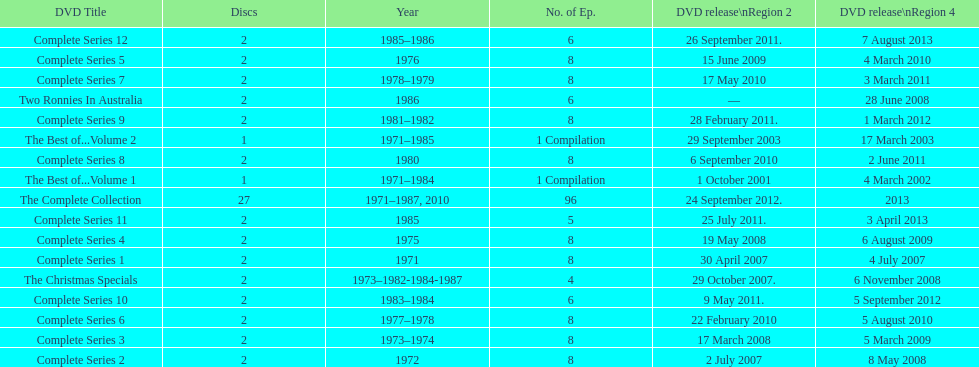Dvd shorter than 5 episodes The Christmas Specials. 